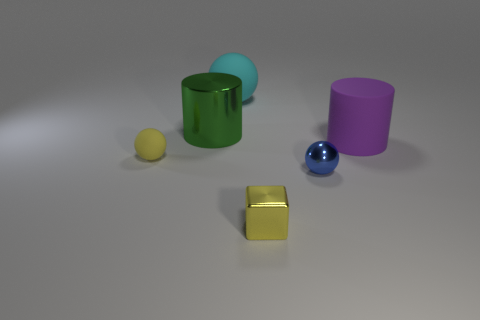Subtract all tiny spheres. How many spheres are left? 1 Add 3 tiny cubes. How many objects exist? 9 Subtract all blocks. How many objects are left? 5 Add 3 tiny yellow shiny objects. How many tiny yellow shiny objects are left? 4 Add 1 small yellow metal blocks. How many small yellow metal blocks exist? 2 Subtract 0 red blocks. How many objects are left? 6 Subtract all green spheres. Subtract all blue cylinders. How many spheres are left? 3 Subtract all large purple things. Subtract all tiny yellow spheres. How many objects are left? 4 